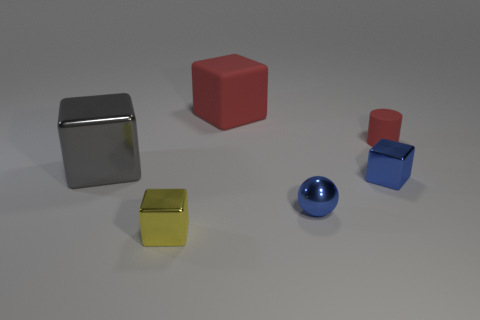Is there any other thing that is the same shape as the tiny red rubber thing?
Provide a succinct answer. No. Is the number of blue metal things in front of the small blue metal ball greater than the number of red things?
Offer a terse response. No. How many objects are in front of the blue metal cube and left of the small ball?
Keep it short and to the point. 1. What is the color of the cube that is behind the block that is on the left side of the yellow object?
Provide a succinct answer. Red. What number of small matte things are the same color as the tiny shiny ball?
Make the answer very short. 0. Do the sphere and the large thing behind the big gray shiny block have the same color?
Make the answer very short. No. Is the number of metallic blocks less than the number of small metal spheres?
Your answer should be compact. No. Are there more red matte things that are on the left side of the tiny sphere than tiny metal cubes that are on the left side of the gray metallic object?
Your answer should be compact. Yes. Is the material of the cylinder the same as the yellow block?
Offer a very short reply. No. How many red rubber objects are right of the shiny block that is to the right of the big rubber thing?
Keep it short and to the point. 1. 